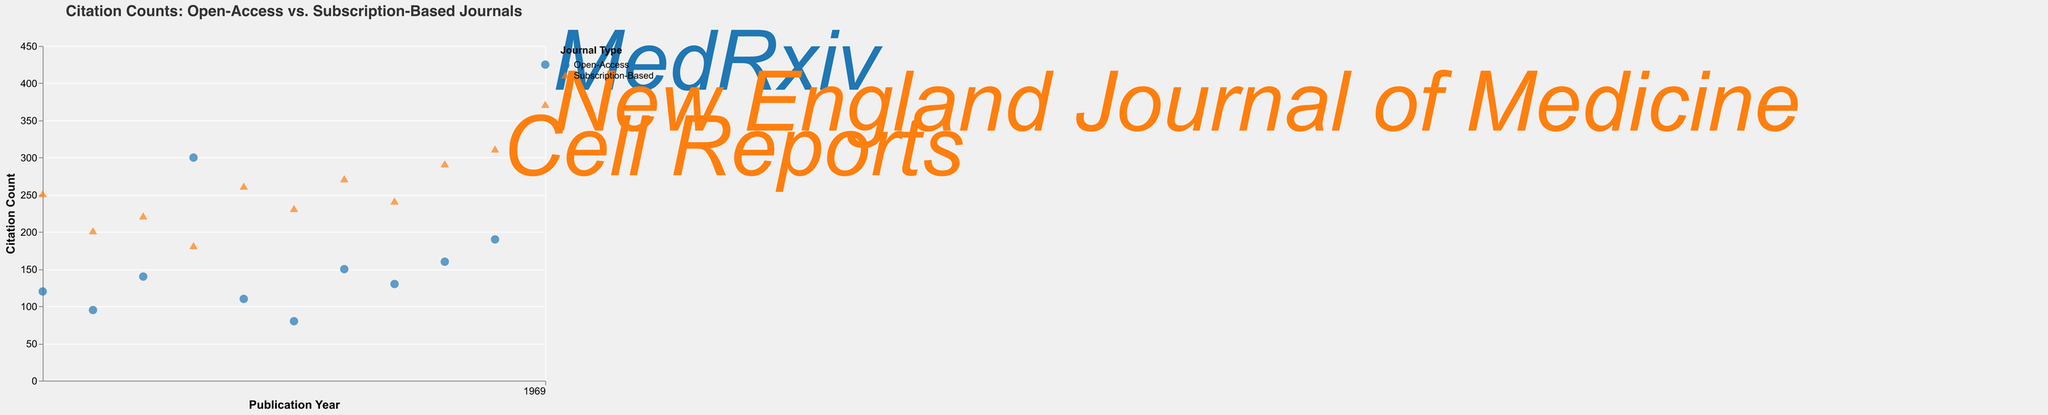What is the title of the figure? The title is displayed at the top of the figure with larger font size compared to other text elements. It summarizes the main topic of the visualization.
Answer: Citation Counts: Open-Access vs. Subscription-Based Journals How many data points represent citation counts for open-access journals? Identify the data points colored blue (assuming open-access is represented by blue) and count them.
Answer: 10 Which year has the highest citation count for a subscription-based journal, and what is the citation count? Locate the data points colored orange (assuming subscription-based is orange). Identify the data point with the highest y-value. The tooltip or label can provide the exact citation count and year.
Answer: 2019, 310 What is the average citation count for open-access journals between 2010 and 2015? Identify and sum the y-values for open-access data points from 2010 to 2015. Divide by the number of points. (120 + 95 + 140 + 300 + 110) / 5
Answer: 153 Compare the citation counts for the highest-cited open-access and subscription-based papers. Which paper has more citations and by how much? Identify the highest y-values for each JournalType (open-access and subscription-based) and subtract the smaller value from the larger. Open-access highest is 425, subscription-based highest is 370.
Answer: Open-access, by 55 Which journal has the marked citation count greater than 400 for open-access in 2020? Check the 2020 data points for open-access (blue) and identify the one with citation count greater than 400 using the labels or tooltips.
Answer: MedRxiv Between 2016 and 2018, which type of journal has a higher average citation count? Sum the citation counts for both journal types in the specified years (2016, 2017, 2018). Compute the average for each type and compare.
Answer: Subscription-based journals In which year did the citation count for open-access journals peak, and what was the paper title? Look for the highest y-value among open-access data points. Identify the corresponding year and paper title using the labels or tooltips.
Answer: 2020, SARS-CoV-2 Research What is the total citation count for subscription-based journals in 2014 and 2015? Sum the citation counts for subscription-based data points in 2014 and 2015. Add the values. (260 + 230)
Answer: 490 How do citation trends over time differ between open-access and subscription-based journals? Observe the overall trends in the y-values for both colors/shapes over the years and note general patterns like increases, decreases, or consistency.
Answer: Open-access has an increasing trend; subscription-based fluctuates 